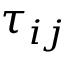Convert formula to latex. <formula><loc_0><loc_0><loc_500><loc_500>\tau _ { i j }</formula> 